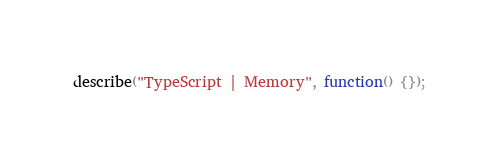<code> <loc_0><loc_0><loc_500><loc_500><_Haxe_>describe("TypeScript | Memory", function() {});
</code> 